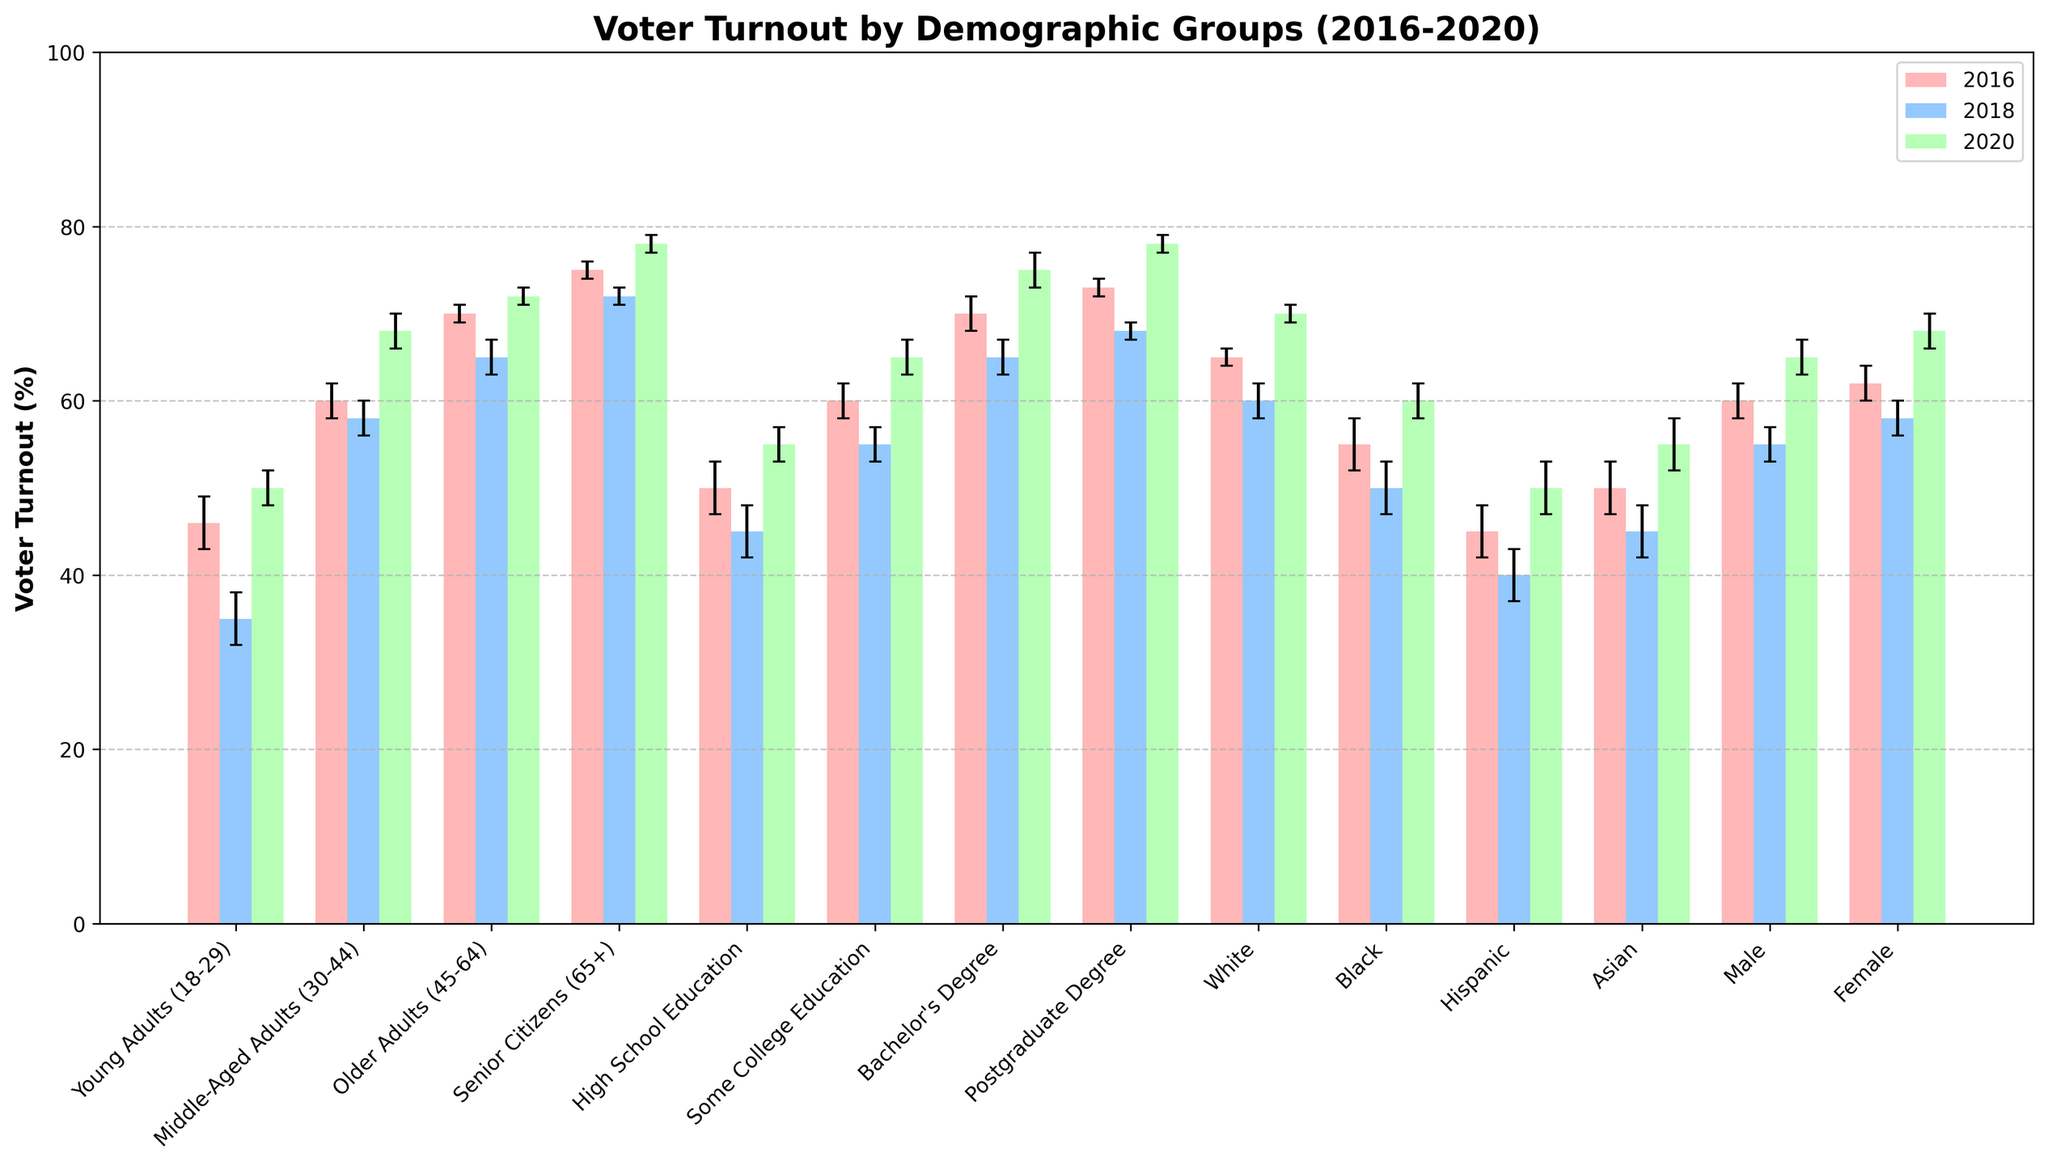What is the title of the figure? The title is usually located at the top center of the figure in a larger, bold font, indicating what the chart represents.
Answer: Voter Turnout by Demographic Groups (2016-2020) Which demographic group had the highest voter turnout in 2020? Look at the bars that represent the 2020 voter turnout for each demographic group and identify the tallest one.
Answer: Senior Citizens (65+) How does the voter turnout of Young Adults (18-29) in 2016 compare to 2018? Find the bar heights for Young Adults in 2016 and 2018 and compare them to see the difference.
Answer: Higher in 2016 Which gender had a greater voter turnout in 2020, Male or Female? Compare the height of the 2020 bars for Male and Female demographic groups.
Answer: Female What was the average turnout across all demographic groups in 2018? Sum the voter turnout percentages for all groups in 2018 and divide by the number of groups.
Answer: 56.7% What is the margin of error for Middle-Aged Adults (30-44) in 2018? Identify the error bars representing the margin of error for the Middle-Aged Adults group in 2018.
Answer: 2% Was there a consistent increase in turnout from 2016 to 2020 for Older Adults (45-64)? Compare the heights of the bars representing Older Adults in 2016, 2018, and 2020 sequentially.
Answer: No Which year had the lowest turnout for Hispanic voters? Identify and compare the bar heights for Hispanic voters across 2016, 2018, and 2020 to find the lowest one.
Answer: 2018 Among the educational groups, who showed the largest increase in turnout from 2018 to 2020? Calculate the difference between the 2018 and 2020 turnouts for each education group, and identify the largest increase.
Answer: High School Education Which demographic group had the smallest margin of error in 2020? Look for the smallest error bars for the year 2020 across all demographic groups.
Answer: Senior Citizens (65+), Older Adults (45-64), Postgraduate Degree, and White 